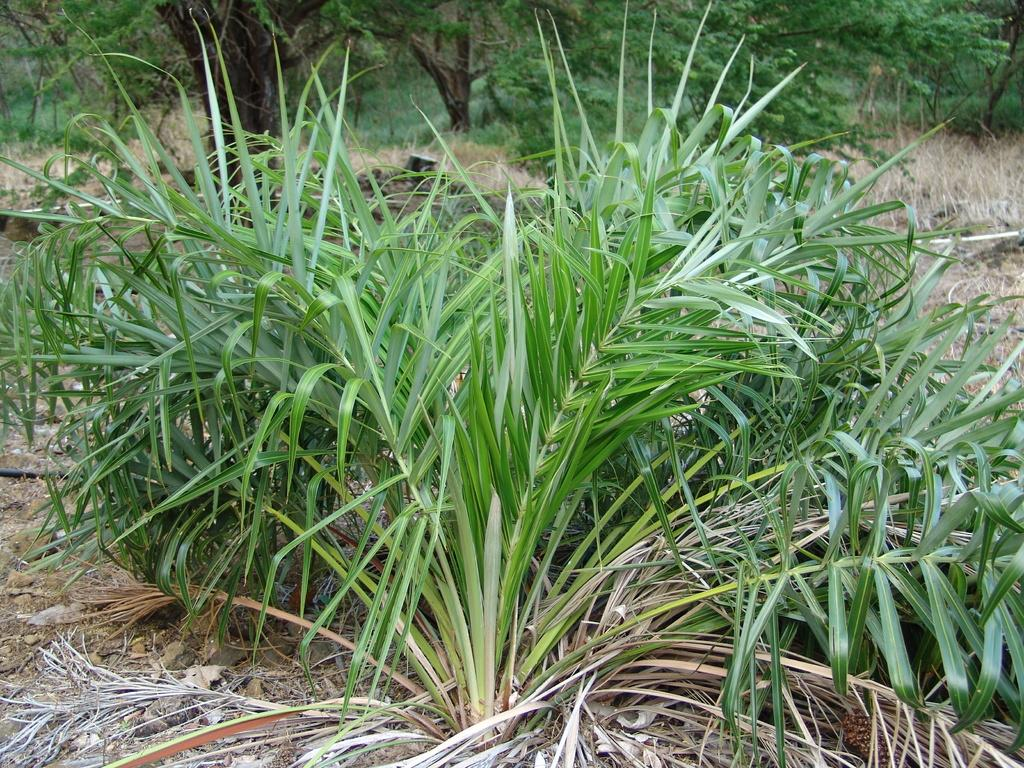What type of vegetation can be seen in the image? There are trees in the image. What else can be found on the ground in the image? There is lawn straw in the image. Is there a note attached to the trees in the image? There is no mention of a note in the provided facts, so it cannot be determined if there is one in the image. 